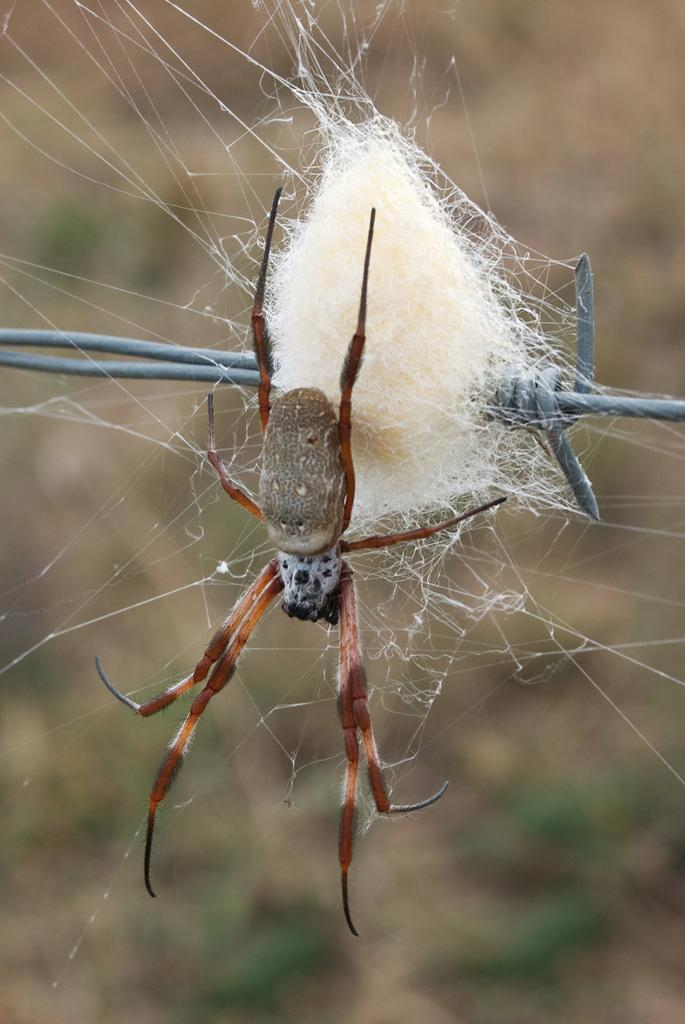What is the main subject of the image? There is a spider in the image. Where is the spider located? The spider is on a fencing. Can you describe the background of the image? The background of the image is blurred. What type of yoke can be seen in the image? There is no yoke present in the image. How many bears are visible in the image? There are no bears visible in the image. 